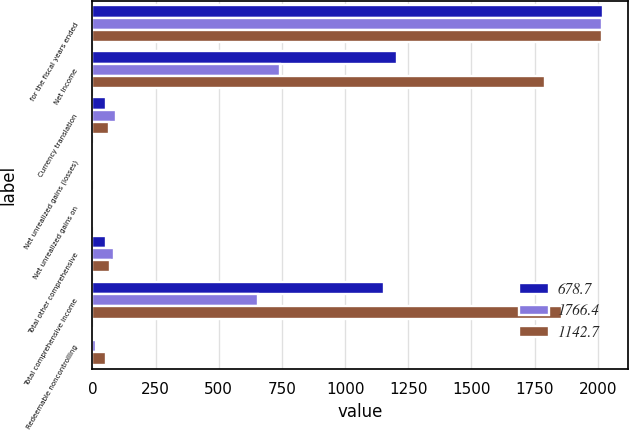<chart> <loc_0><loc_0><loc_500><loc_500><stacked_bar_chart><ecel><fcel>for the fiscal years ended<fcel>Net Income<fcel>Currency translation<fcel>Net unrealized gains (losses)<fcel>Net unrealized gains on<fcel>Total other comprehensive<fcel>Total comprehensive income<fcel>Redeemable noncontrolling<nl><fcel>678.7<fcel>2019<fcel>1205.5<fcel>52.5<fcel>2<fcel>1.5<fcel>53<fcel>1152.5<fcel>6.2<nl><fcel>1766.4<fcel>2018<fcel>742.7<fcel>91.9<fcel>1.9<fcel>4.3<fcel>85.7<fcel>657<fcel>12.8<nl><fcel>1142.7<fcel>2017<fcel>1789.7<fcel>65.4<fcel>2.1<fcel>2.2<fcel>69.7<fcel>1859.4<fcel>53<nl></chart> 